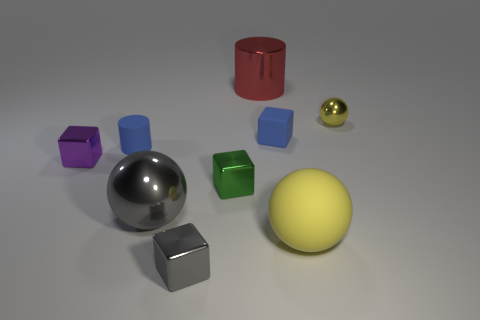Subtract all red cylinders. Subtract all red spheres. How many cylinders are left? 1 Subtract all balls. How many objects are left? 6 Add 5 big red metal cylinders. How many big red metal cylinders exist? 6 Subtract 0 red spheres. How many objects are left? 9 Subtract all large shiny balls. Subtract all small yellow rubber things. How many objects are left? 8 Add 4 big red metallic things. How many big red metallic things are left? 5 